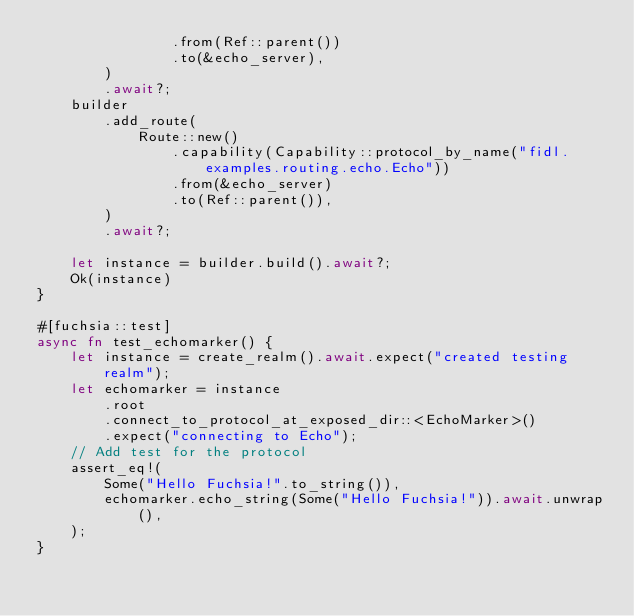<code> <loc_0><loc_0><loc_500><loc_500><_Rust_>                .from(Ref::parent())
                .to(&echo_server),
        )
        .await?;
    builder
        .add_route(
            Route::new()
                .capability(Capability::protocol_by_name("fidl.examples.routing.echo.Echo"))
                .from(&echo_server)
                .to(Ref::parent()),
        )
        .await?;

    let instance = builder.build().await?;
    Ok(instance)
}

#[fuchsia::test]
async fn test_echomarker() {
    let instance = create_realm().await.expect("created testing realm");
    let echomarker = instance
        .root
        .connect_to_protocol_at_exposed_dir::<EchoMarker>()
        .expect("connecting to Echo");
    // Add test for the protocol
    assert_eq!(
        Some("Hello Fuchsia!".to_string()),
        echomarker.echo_string(Some("Hello Fuchsia!")).await.unwrap(),
    );
}
</code> 